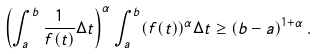Convert formula to latex. <formula><loc_0><loc_0><loc_500><loc_500>\left ( \int _ { a } ^ { b } \frac { 1 } { f ( t ) } \Delta t \right ) ^ { \alpha } \int _ { a } ^ { b } ( f ( t ) ) ^ { \alpha } \Delta t \geq ( b - a ) ^ { 1 + \alpha } \, .</formula> 